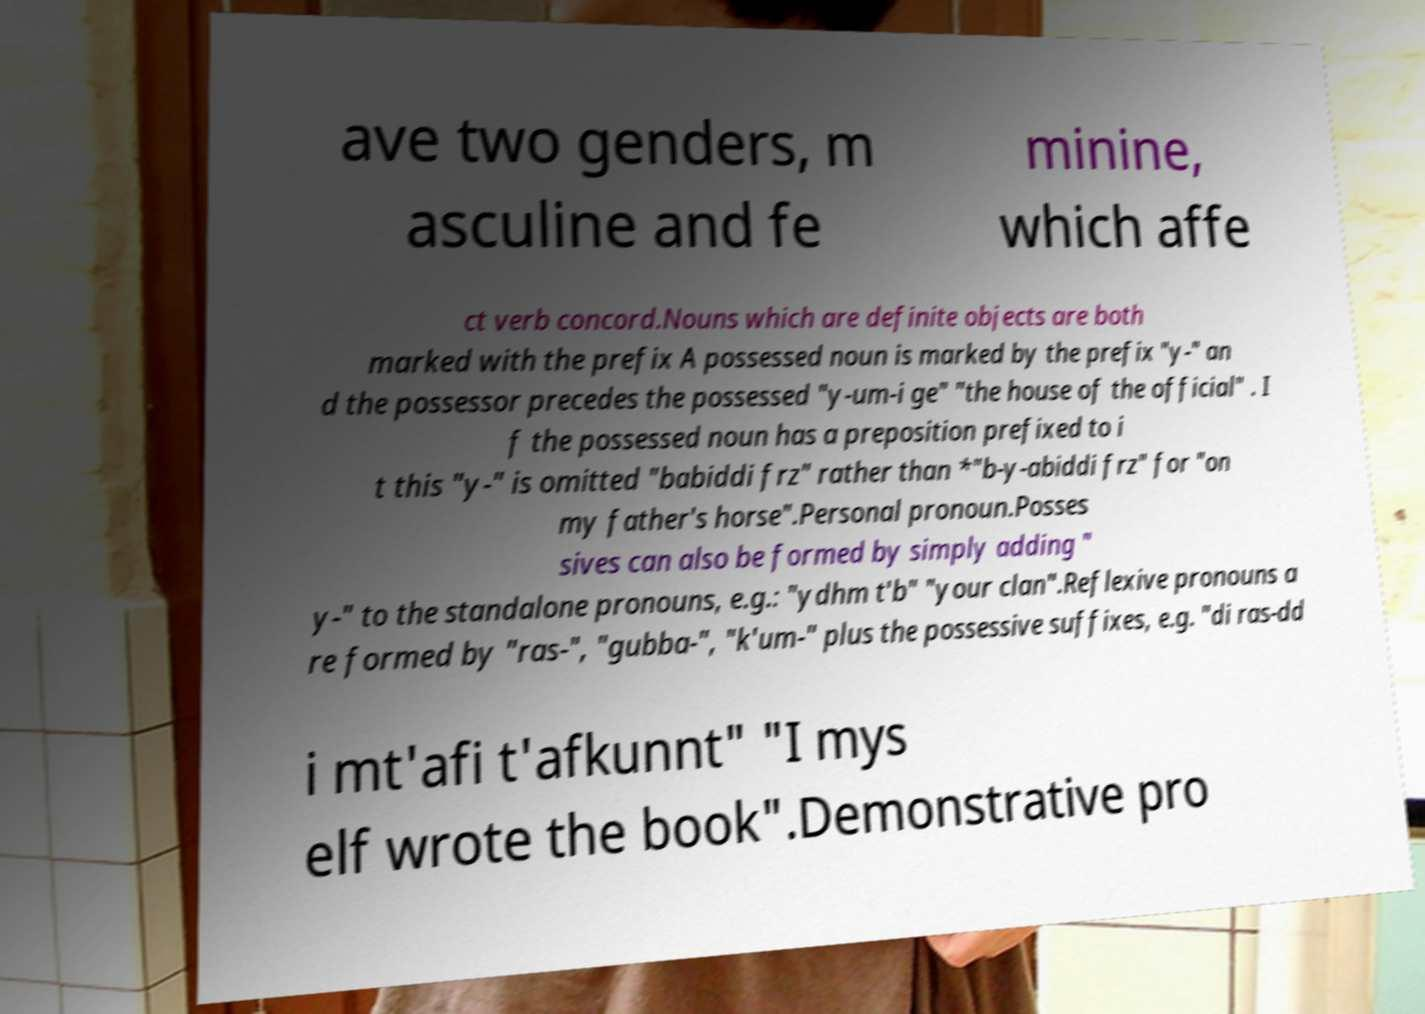Could you assist in decoding the text presented in this image and type it out clearly? ave two genders, m asculine and fe minine, which affe ct verb concord.Nouns which are definite objects are both marked with the prefix A possessed noun is marked by the prefix "y-" an d the possessor precedes the possessed "y-um-i ge" "the house of the official" . I f the possessed noun has a preposition prefixed to i t this "y-" is omitted "babiddi frz" rather than *"b-y-abiddi frz" for "on my father's horse".Personal pronoun.Posses sives can also be formed by simply adding " y-" to the standalone pronouns, e.g.: "ydhm t'b" "your clan".Reflexive pronouns a re formed by "ras-", "gubba-", "k'um-" plus the possessive suffixes, e.g. "di ras-dd i mt'afi t'afkunnt" "I mys elf wrote the book".Demonstrative pro 